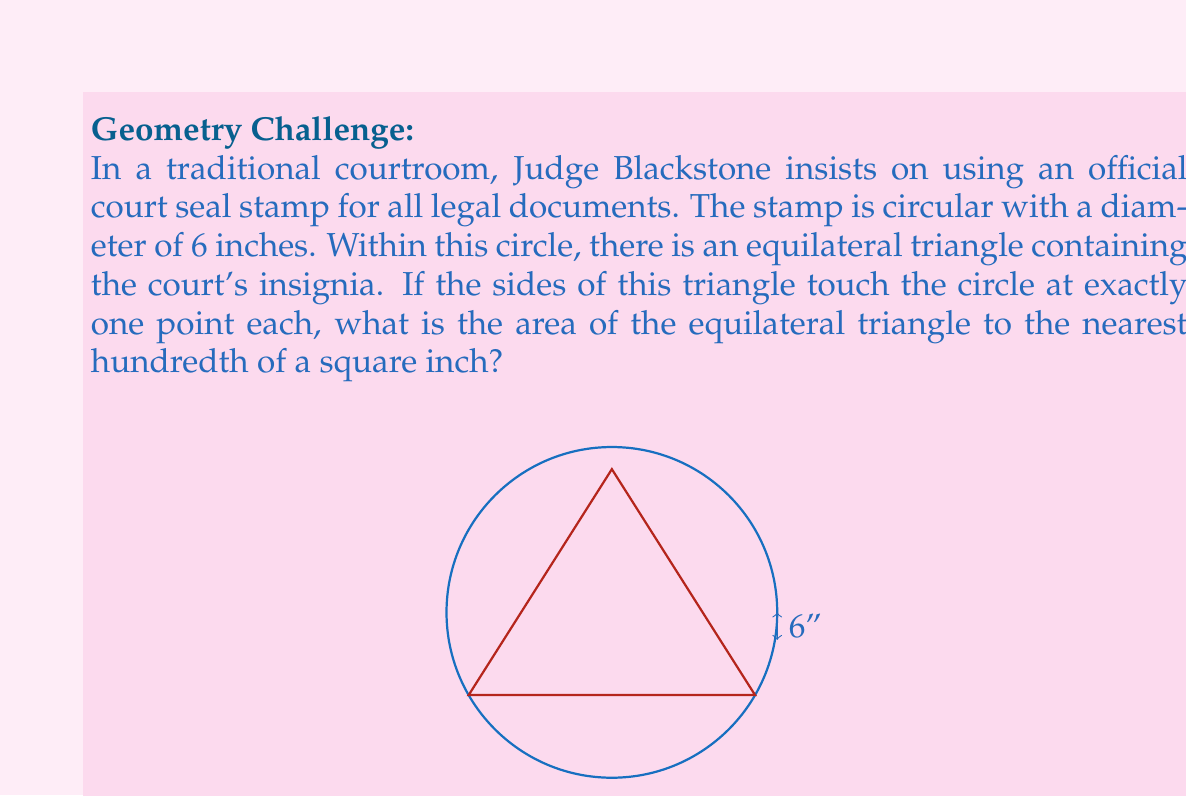Show me your answer to this math problem. Let's approach this step-by-step:

1) The radius of the circle is half the diameter: $r = 6/2 = 3$ inches.

2) In an equilateral triangle inscribed in a circle such that each side touches the circle at one point, the relationship between the side length of the triangle ($s$) and the radius of the circle ($r$) is:

   $$s = r\sqrt{3}$$

3) Substituting our radius:
   
   $$s = 3\sqrt{3}$$ inches

4) The area of an equilateral triangle with side length $s$ is given by:

   $$A = \frac{\sqrt{3}}{4}s^2$$

5) Substituting our side length:

   $$\begin{align}
   A &= \frac{\sqrt{3}}{4}(3\sqrt{3})^2 \\
   &= \frac{\sqrt{3}}{4}(27) \\
   &= \frac{27\sqrt{3}}{4}
   \end{align}$$

6) Evaluating this:

   $$\frac{27\sqrt{3}}{4} \approx 11.69$$ square inches

7) Rounding to the nearest hundredth:

   $11.69$ square inches
Answer: The area of the equilateral triangle is 11.69 square inches. 